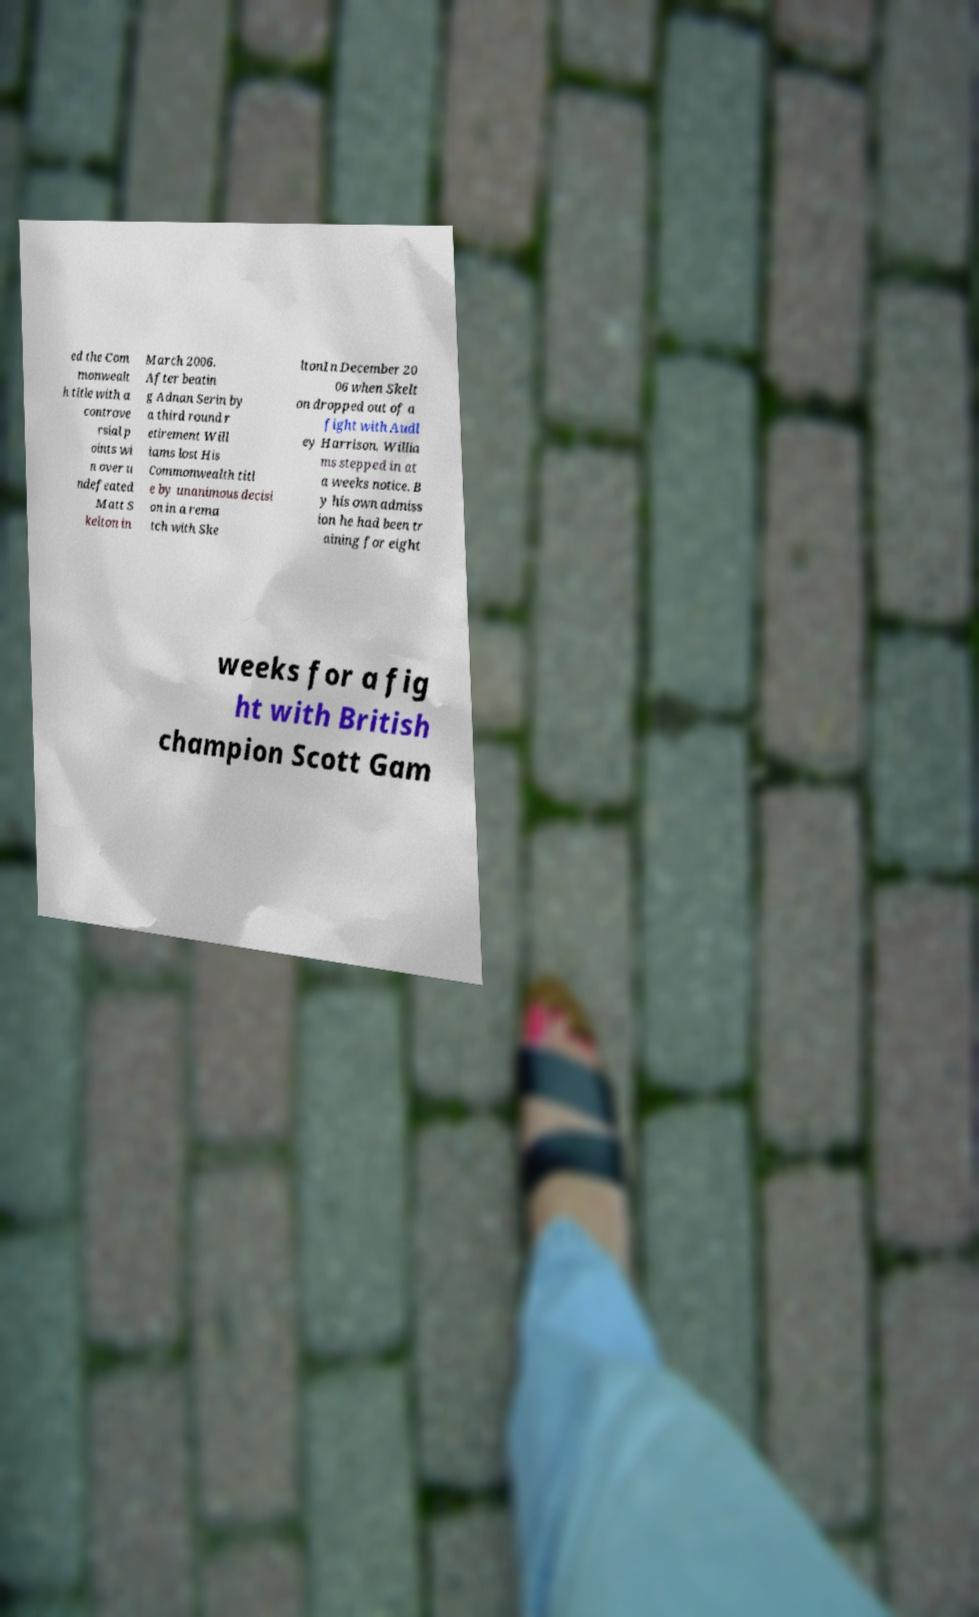Could you assist in decoding the text presented in this image and type it out clearly? ed the Com monwealt h title with a controve rsial p oints wi n over u ndefeated Matt S kelton in March 2006. After beatin g Adnan Serin by a third round r etirement Will iams lost His Commonwealth titl e by unanimous decisi on in a rema tch with Ske ltonIn December 20 06 when Skelt on dropped out of a fight with Audl ey Harrison, Willia ms stepped in at a weeks notice. B y his own admiss ion he had been tr aining for eight weeks for a fig ht with British champion Scott Gam 